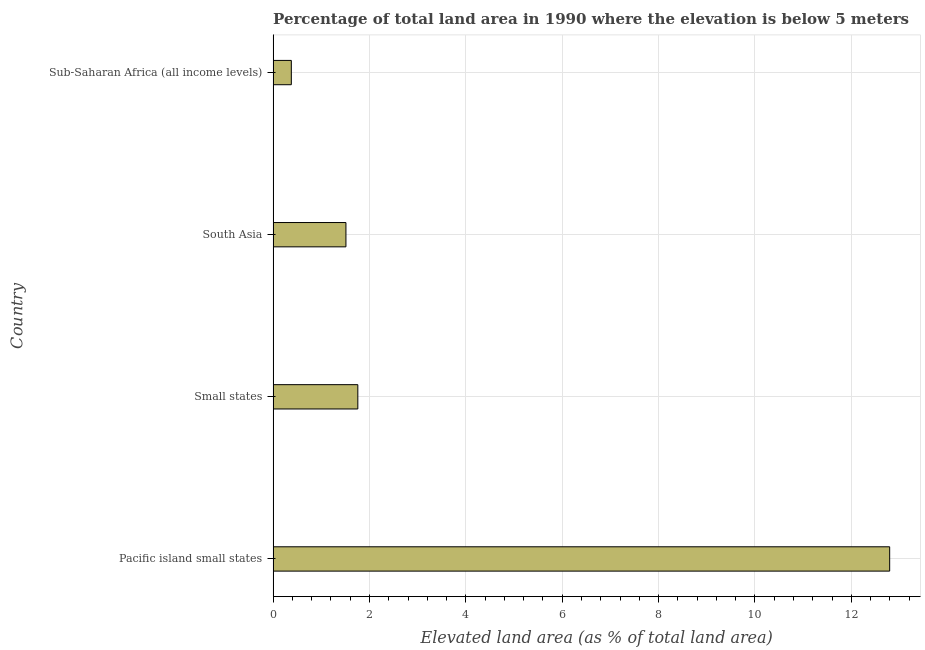Does the graph contain grids?
Provide a succinct answer. Yes. What is the title of the graph?
Give a very brief answer. Percentage of total land area in 1990 where the elevation is below 5 meters. What is the label or title of the X-axis?
Keep it short and to the point. Elevated land area (as % of total land area). What is the total elevated land area in Sub-Saharan Africa (all income levels)?
Offer a very short reply. 0.38. Across all countries, what is the maximum total elevated land area?
Ensure brevity in your answer.  12.79. Across all countries, what is the minimum total elevated land area?
Give a very brief answer. 0.38. In which country was the total elevated land area maximum?
Make the answer very short. Pacific island small states. In which country was the total elevated land area minimum?
Provide a short and direct response. Sub-Saharan Africa (all income levels). What is the sum of the total elevated land area?
Your answer should be very brief. 16.44. What is the difference between the total elevated land area in Pacific island small states and Small states?
Offer a terse response. 11.04. What is the average total elevated land area per country?
Provide a short and direct response. 4.11. What is the median total elevated land area?
Provide a short and direct response. 1.63. In how many countries, is the total elevated land area greater than 10.8 %?
Offer a terse response. 1. What is the ratio of the total elevated land area in Pacific island small states to that in Sub-Saharan Africa (all income levels)?
Give a very brief answer. 33.85. Is the total elevated land area in Pacific island small states less than that in Sub-Saharan Africa (all income levels)?
Give a very brief answer. No. Is the difference between the total elevated land area in Pacific island small states and South Asia greater than the difference between any two countries?
Ensure brevity in your answer.  No. What is the difference between the highest and the second highest total elevated land area?
Offer a terse response. 11.04. Is the sum of the total elevated land area in Pacific island small states and Small states greater than the maximum total elevated land area across all countries?
Your response must be concise. Yes. What is the difference between the highest and the lowest total elevated land area?
Give a very brief answer. 12.42. How many bars are there?
Your answer should be very brief. 4. How many countries are there in the graph?
Your response must be concise. 4. What is the difference between two consecutive major ticks on the X-axis?
Offer a very short reply. 2. Are the values on the major ticks of X-axis written in scientific E-notation?
Provide a short and direct response. No. What is the Elevated land area (as % of total land area) in Pacific island small states?
Give a very brief answer. 12.79. What is the Elevated land area (as % of total land area) in Small states?
Provide a short and direct response. 1.76. What is the Elevated land area (as % of total land area) in South Asia?
Your answer should be very brief. 1.51. What is the Elevated land area (as % of total land area) of Sub-Saharan Africa (all income levels)?
Ensure brevity in your answer.  0.38. What is the difference between the Elevated land area (as % of total land area) in Pacific island small states and Small states?
Provide a succinct answer. 11.04. What is the difference between the Elevated land area (as % of total land area) in Pacific island small states and South Asia?
Make the answer very short. 11.28. What is the difference between the Elevated land area (as % of total land area) in Pacific island small states and Sub-Saharan Africa (all income levels)?
Your answer should be compact. 12.42. What is the difference between the Elevated land area (as % of total land area) in Small states and South Asia?
Ensure brevity in your answer.  0.25. What is the difference between the Elevated land area (as % of total land area) in Small states and Sub-Saharan Africa (all income levels)?
Offer a terse response. 1.38. What is the difference between the Elevated land area (as % of total land area) in South Asia and Sub-Saharan Africa (all income levels)?
Offer a very short reply. 1.13. What is the ratio of the Elevated land area (as % of total land area) in Pacific island small states to that in Small states?
Provide a succinct answer. 7.28. What is the ratio of the Elevated land area (as % of total land area) in Pacific island small states to that in South Asia?
Provide a short and direct response. 8.47. What is the ratio of the Elevated land area (as % of total land area) in Pacific island small states to that in Sub-Saharan Africa (all income levels)?
Offer a very short reply. 33.85. What is the ratio of the Elevated land area (as % of total land area) in Small states to that in South Asia?
Keep it short and to the point. 1.16. What is the ratio of the Elevated land area (as % of total land area) in Small states to that in Sub-Saharan Africa (all income levels)?
Offer a very short reply. 4.65. What is the ratio of the Elevated land area (as % of total land area) in South Asia to that in Sub-Saharan Africa (all income levels)?
Your answer should be compact. 4. 